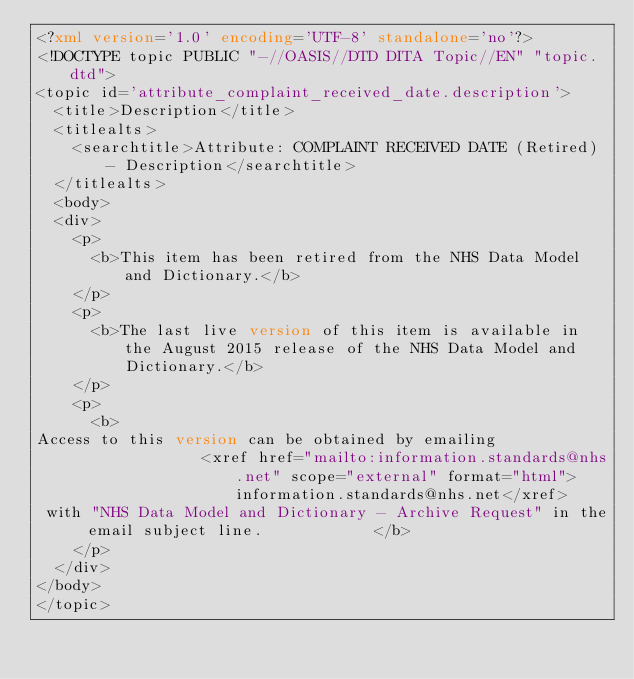Convert code to text. <code><loc_0><loc_0><loc_500><loc_500><_XML_><?xml version='1.0' encoding='UTF-8' standalone='no'?>
<!DOCTYPE topic PUBLIC "-//OASIS//DTD DITA Topic//EN" "topic.dtd">
<topic id='attribute_complaint_received_date.description'>
  <title>Description</title>
  <titlealts>
    <searchtitle>Attribute: COMPLAINT RECEIVED DATE (Retired) - Description</searchtitle>
  </titlealts>
  <body>
  <div>
    <p>
      <b>This item has been retired from the NHS Data Model and Dictionary.</b>
    </p>
    <p>
      <b>The last live version of this item is available in the August 2015 release of the NHS Data Model and Dictionary.</b>
    </p>
    <p>
      <b>
Access to this version can be obtained by emailing 
                  <xref href="mailto:information.standards@nhs.net" scope="external" format="html">information.standards@nhs.net</xref>
 with "NHS Data Model and Dictionary - Archive Request" in the email subject line.            </b>
    </p>
  </div>
</body>
</topic></code> 